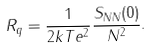Convert formula to latex. <formula><loc_0><loc_0><loc_500><loc_500>R _ { q } = \frac { 1 } { 2 k T e ^ { 2 } } \frac { S _ { N N } ( 0 ) } { N ^ { 2 } } .</formula> 